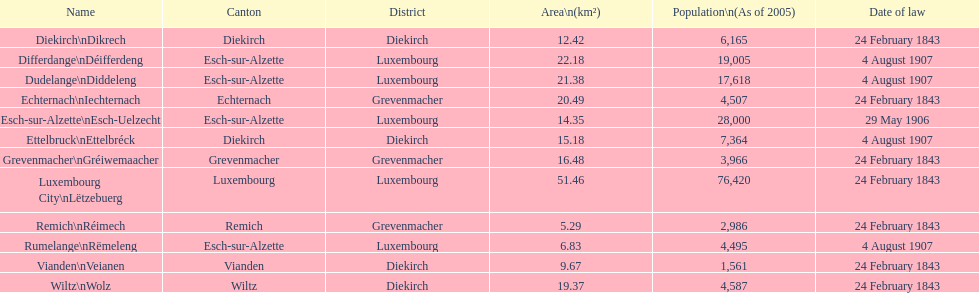What is the number of diekirch districts where diekirch serves as the canton as well? 2. Can you give me this table as a dict? {'header': ['Name', 'Canton', 'District', 'Area\\n(km²)', 'Population\\n(As of 2005)', 'Date of law'], 'rows': [['Diekirch\\nDikrech', 'Diekirch', 'Diekirch', '12.42', '6,165', '24 February 1843'], ['Differdange\\nDéifferdeng', 'Esch-sur-Alzette', 'Luxembourg', '22.18', '19,005', '4 August 1907'], ['Dudelange\\nDiddeleng', 'Esch-sur-Alzette', 'Luxembourg', '21.38', '17,618', '4 August 1907'], ['Echternach\\nIechternach', 'Echternach', 'Grevenmacher', '20.49', '4,507', '24 February 1843'], ['Esch-sur-Alzette\\nEsch-Uelzecht', 'Esch-sur-Alzette', 'Luxembourg', '14.35', '28,000', '29 May 1906'], ['Ettelbruck\\nEttelbréck', 'Diekirch', 'Diekirch', '15.18', '7,364', '4 August 1907'], ['Grevenmacher\\nGréiwemaacher', 'Grevenmacher', 'Grevenmacher', '16.48', '3,966', '24 February 1843'], ['Luxembourg City\\nLëtzebuerg', 'Luxembourg', 'Luxembourg', '51.46', '76,420', '24 February 1843'], ['Remich\\nRéimech', 'Remich', 'Grevenmacher', '5.29', '2,986', '24 February 1843'], ['Rumelange\\nRëmeleng', 'Esch-sur-Alzette', 'Luxembourg', '6.83', '4,495', '4 August 1907'], ['Vianden\\nVeianen', 'Vianden', 'Diekirch', '9.67', '1,561', '24 February 1843'], ['Wiltz\\nWolz', 'Wiltz', 'Diekirch', '19.37', '4,587', '24 February 1843']]} 